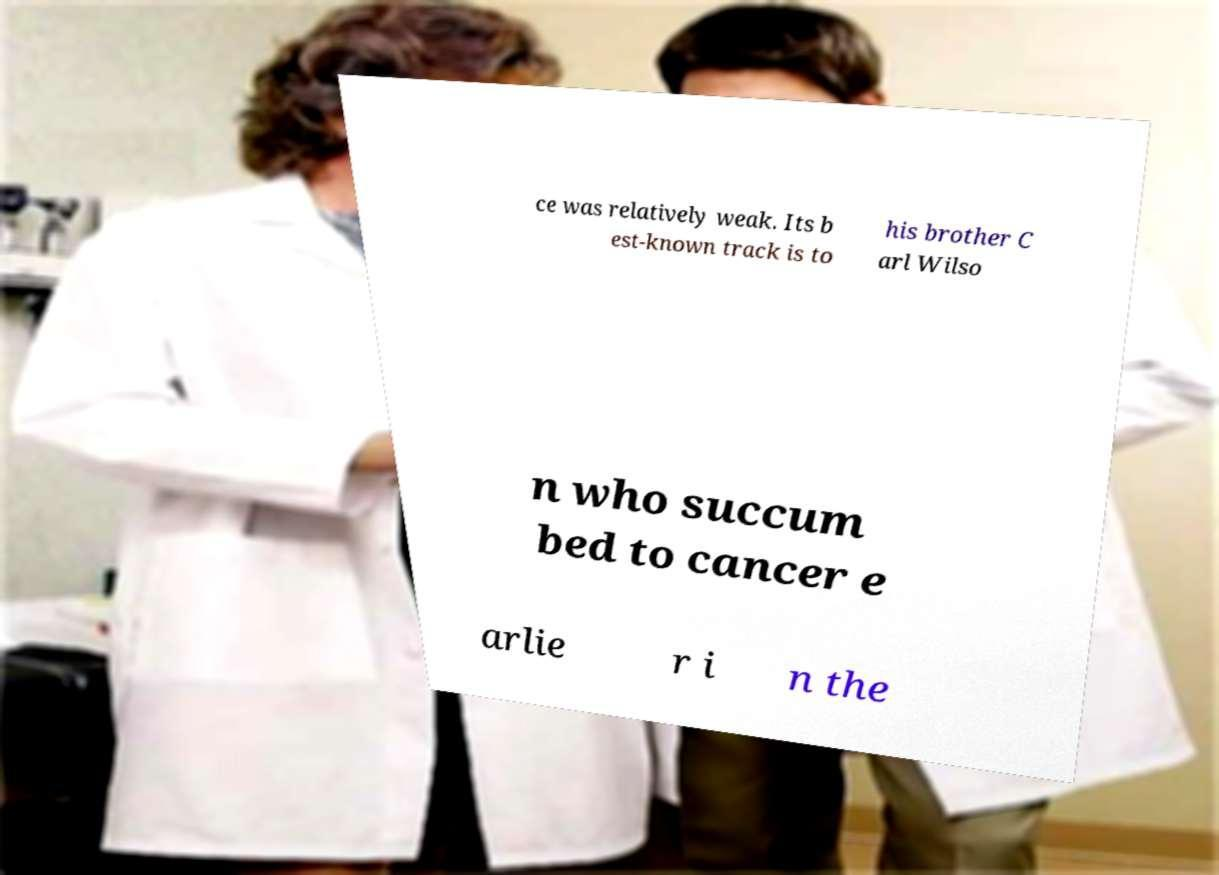Can you accurately transcribe the text from the provided image for me? ce was relatively weak. Its b est-known track is to his brother C arl Wilso n who succum bed to cancer e arlie r i n the 